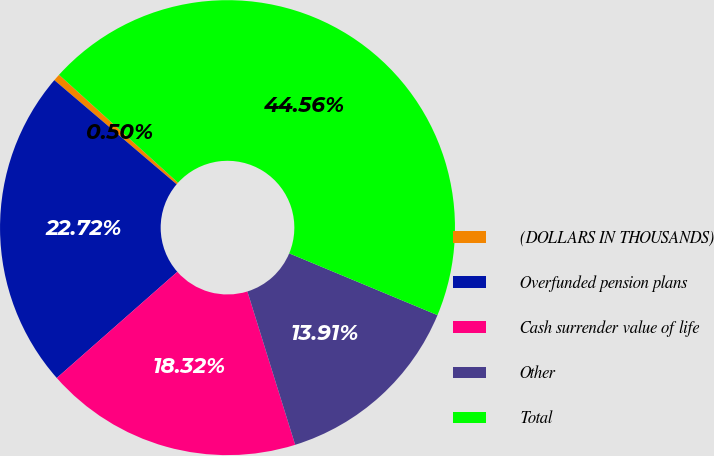Convert chart to OTSL. <chart><loc_0><loc_0><loc_500><loc_500><pie_chart><fcel>(DOLLARS IN THOUSANDS)<fcel>Overfunded pension plans<fcel>Cash surrender value of life<fcel>Other<fcel>Total<nl><fcel>0.5%<fcel>22.72%<fcel>18.32%<fcel>13.91%<fcel>44.56%<nl></chart> 